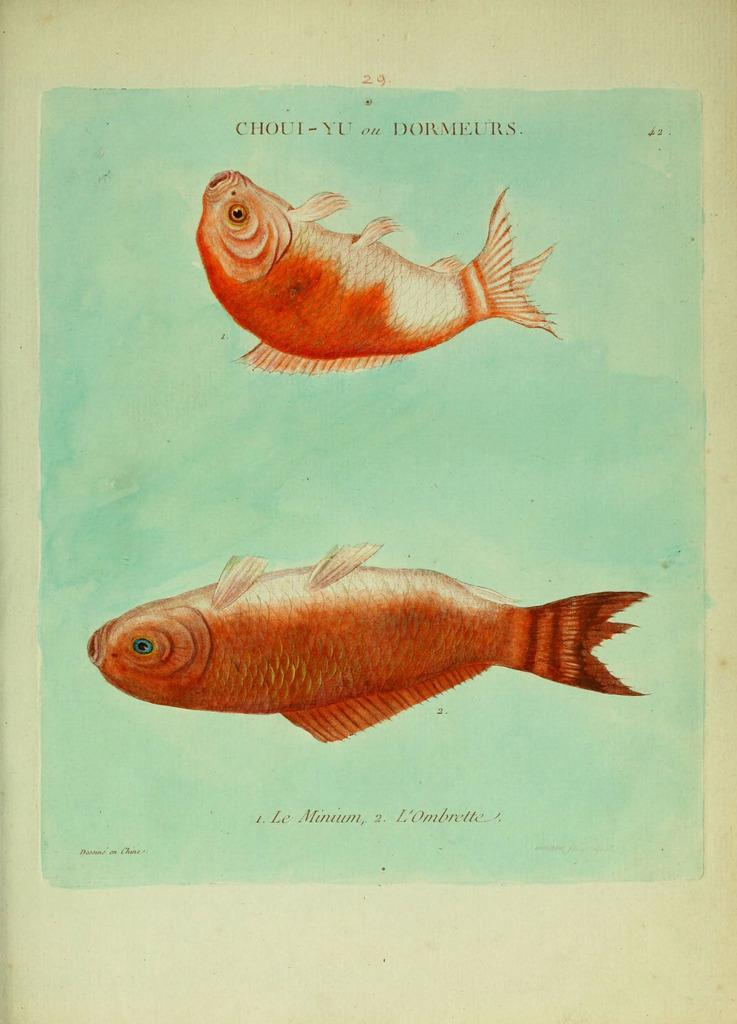What is present in the image? There is a paper in the image. What is depicted on the paper? The paper has fish paintings on it. What type of bait is used for fishing in the image? There is no fishing or bait present in the image; it only features a paper with fish paintings. 